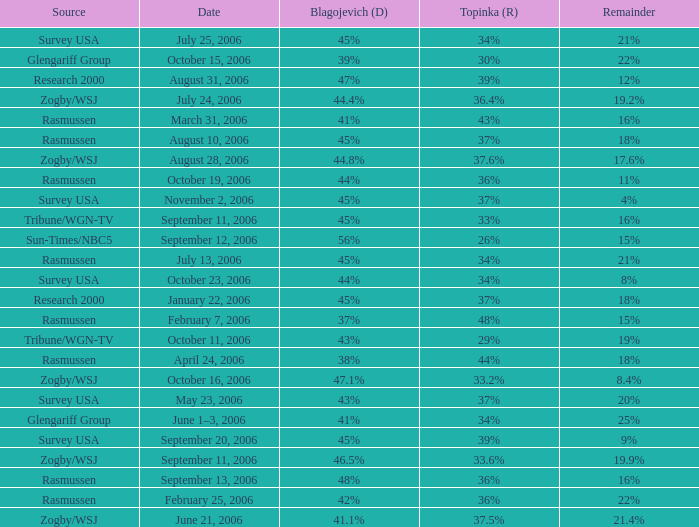Which Blagojevich (D) has a Source of zogby/wsj, and a Topinka (R) of 33.2%? 47.1%. 